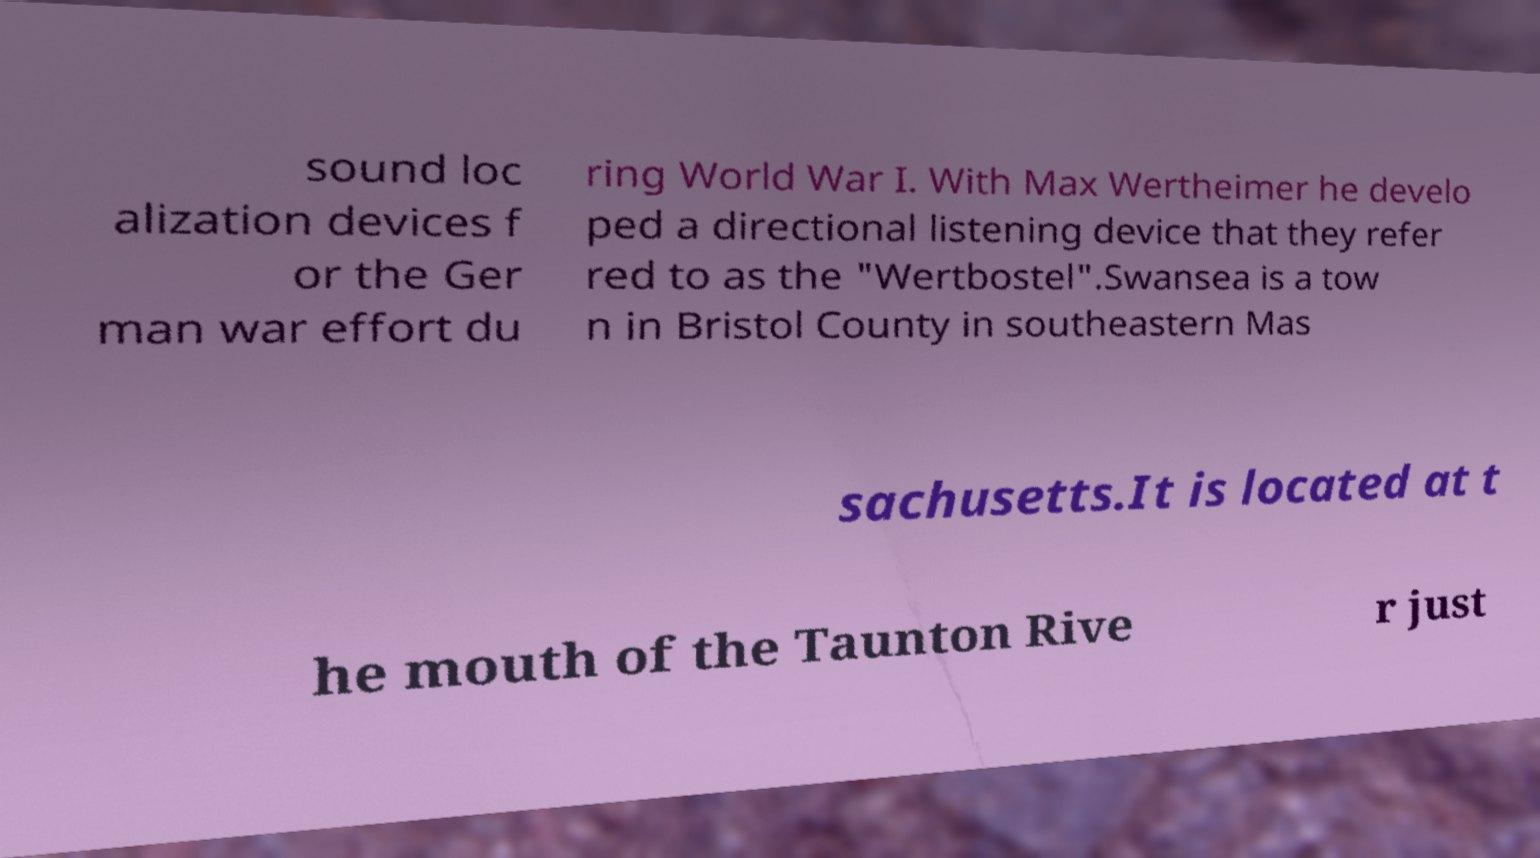For documentation purposes, I need the text within this image transcribed. Could you provide that? sound loc alization devices f or the Ger man war effort du ring World War I. With Max Wertheimer he develo ped a directional listening device that they refer red to as the "Wertbostel".Swansea is a tow n in Bristol County in southeastern Mas sachusetts.It is located at t he mouth of the Taunton Rive r just 